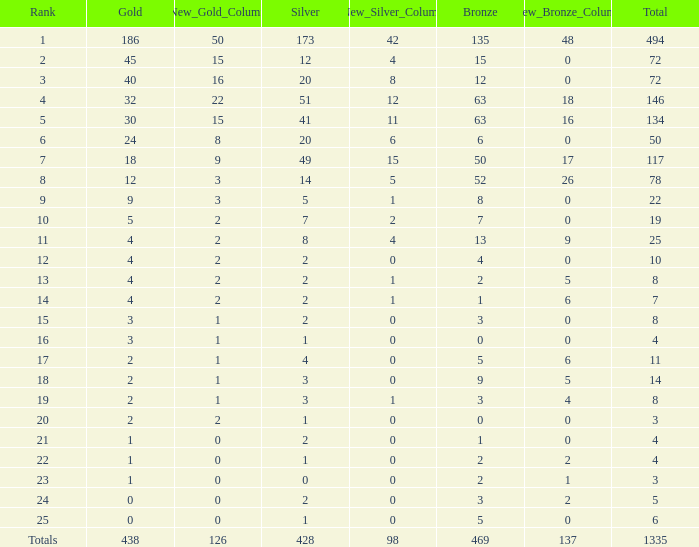What is the average number of gold medals when the total was 1335 medals, with more than 469 bronzes and more than 14 silvers? None. 